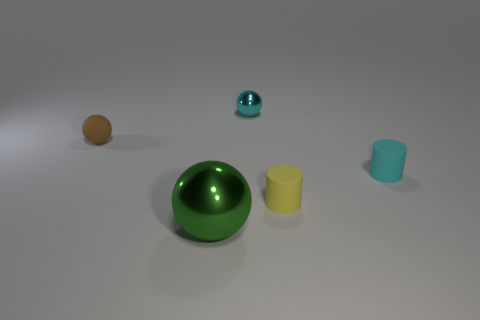Are there any other things that have the same size as the green ball?
Provide a succinct answer. No. Is the shape of the tiny brown matte object the same as the small cyan rubber thing?
Your answer should be compact. No. What is the size of the thing behind the tiny matte object left of the cyan metallic thing?
Keep it short and to the point. Small. There is another rubber object that is the same shape as the tiny yellow thing; what is its color?
Give a very brief answer. Cyan. What number of other small objects are the same color as the small shiny thing?
Make the answer very short. 1. What is the size of the green thing?
Provide a short and direct response. Large. Does the brown rubber ball have the same size as the cyan matte thing?
Give a very brief answer. Yes. There is a ball that is both behind the green thing and right of the small brown ball; what color is it?
Keep it short and to the point. Cyan. What number of other things have the same material as the large object?
Provide a short and direct response. 1. What number of cyan balls are there?
Provide a short and direct response. 1. 